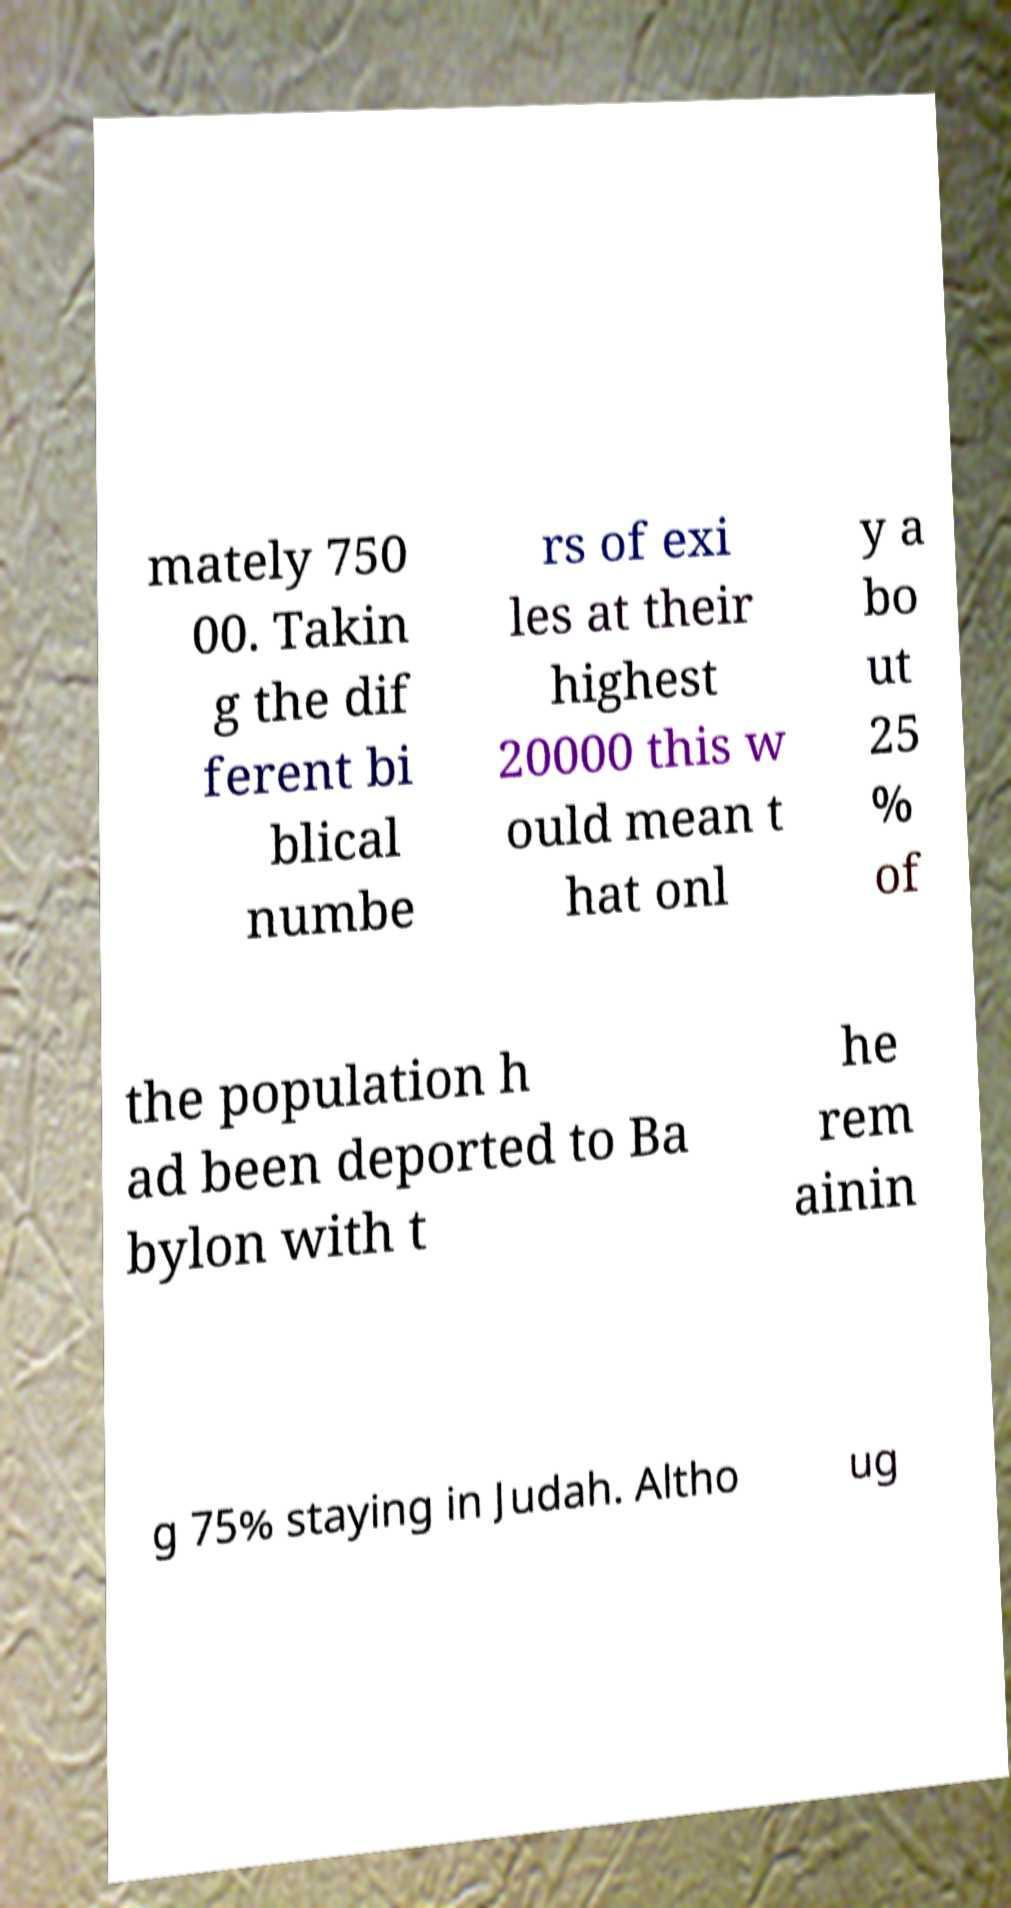Could you extract and type out the text from this image? mately 750 00. Takin g the dif ferent bi blical numbe rs of exi les at their highest 20000 this w ould mean t hat onl y a bo ut 25 % of the population h ad been deported to Ba bylon with t he rem ainin g 75% staying in Judah. Altho ug 